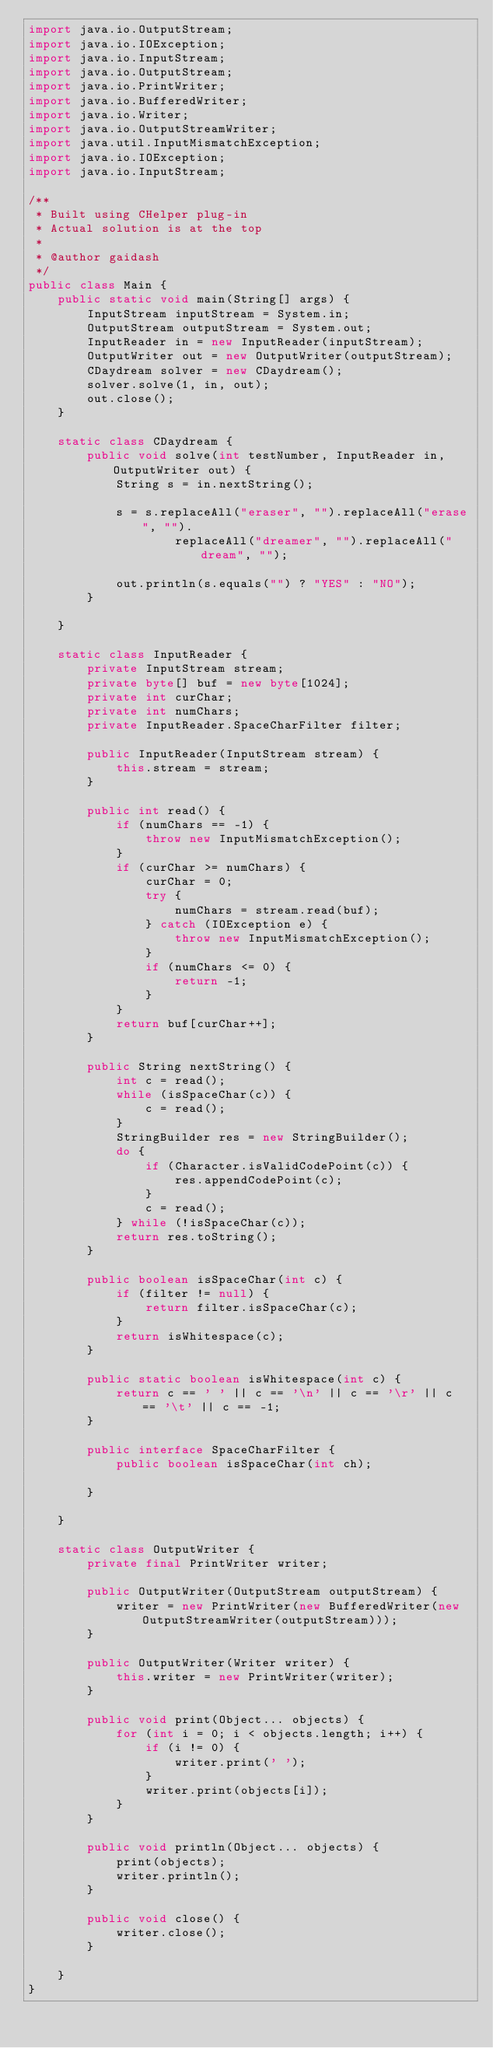<code> <loc_0><loc_0><loc_500><loc_500><_Java_>import java.io.OutputStream;
import java.io.IOException;
import java.io.InputStream;
import java.io.OutputStream;
import java.io.PrintWriter;
import java.io.BufferedWriter;
import java.io.Writer;
import java.io.OutputStreamWriter;
import java.util.InputMismatchException;
import java.io.IOException;
import java.io.InputStream;

/**
 * Built using CHelper plug-in
 * Actual solution is at the top
 *
 * @author gaidash
 */
public class Main {
    public static void main(String[] args) {
        InputStream inputStream = System.in;
        OutputStream outputStream = System.out;
        InputReader in = new InputReader(inputStream);
        OutputWriter out = new OutputWriter(outputStream);
        CDaydream solver = new CDaydream();
        solver.solve(1, in, out);
        out.close();
    }

    static class CDaydream {
        public void solve(int testNumber, InputReader in, OutputWriter out) {
            String s = in.nextString();

            s = s.replaceAll("eraser", "").replaceAll("erase", "").
                    replaceAll("dreamer", "").replaceAll("dream", "");

            out.println(s.equals("") ? "YES" : "NO");
        }

    }

    static class InputReader {
        private InputStream stream;
        private byte[] buf = new byte[1024];
        private int curChar;
        private int numChars;
        private InputReader.SpaceCharFilter filter;

        public InputReader(InputStream stream) {
            this.stream = stream;
        }

        public int read() {
            if (numChars == -1) {
                throw new InputMismatchException();
            }
            if (curChar >= numChars) {
                curChar = 0;
                try {
                    numChars = stream.read(buf);
                } catch (IOException e) {
                    throw new InputMismatchException();
                }
                if (numChars <= 0) {
                    return -1;
                }
            }
            return buf[curChar++];
        }

        public String nextString() {
            int c = read();
            while (isSpaceChar(c)) {
                c = read();
            }
            StringBuilder res = new StringBuilder();
            do {
                if (Character.isValidCodePoint(c)) {
                    res.appendCodePoint(c);
                }
                c = read();
            } while (!isSpaceChar(c));
            return res.toString();
        }

        public boolean isSpaceChar(int c) {
            if (filter != null) {
                return filter.isSpaceChar(c);
            }
            return isWhitespace(c);
        }

        public static boolean isWhitespace(int c) {
            return c == ' ' || c == '\n' || c == '\r' || c == '\t' || c == -1;
        }

        public interface SpaceCharFilter {
            public boolean isSpaceChar(int ch);

        }

    }

    static class OutputWriter {
        private final PrintWriter writer;

        public OutputWriter(OutputStream outputStream) {
            writer = new PrintWriter(new BufferedWriter(new OutputStreamWriter(outputStream)));
        }

        public OutputWriter(Writer writer) {
            this.writer = new PrintWriter(writer);
        }

        public void print(Object... objects) {
            for (int i = 0; i < objects.length; i++) {
                if (i != 0) {
                    writer.print(' ');
                }
                writer.print(objects[i]);
            }
        }

        public void println(Object... objects) {
            print(objects);
            writer.println();
        }

        public void close() {
            writer.close();
        }

    }
}

</code> 